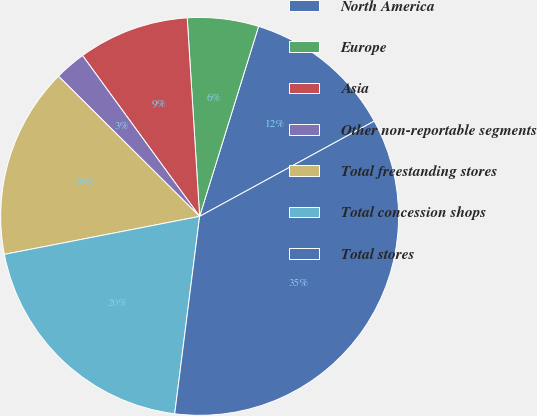<chart> <loc_0><loc_0><loc_500><loc_500><pie_chart><fcel>North America<fcel>Europe<fcel>Asia<fcel>Other non-reportable segments<fcel>Total freestanding stores<fcel>Total concession shops<fcel>Total stores<nl><fcel>12.26%<fcel>5.78%<fcel>9.02%<fcel>2.54%<fcel>15.5%<fcel>19.94%<fcel>34.94%<nl></chart> 